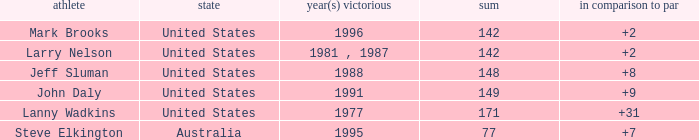Name the To par that has a Year(s) won of 1988 and a Total smaller than 148? None. Can you give me this table as a dict? {'header': ['athlete', 'state', 'year(s) victorious', 'sum', 'in comparison to par'], 'rows': [['Mark Brooks', 'United States', '1996', '142', '+2'], ['Larry Nelson', 'United States', '1981 , 1987', '142', '+2'], ['Jeff Sluman', 'United States', '1988', '148', '+8'], ['John Daly', 'United States', '1991', '149', '+9'], ['Lanny Wadkins', 'United States', '1977', '171', '+31'], ['Steve Elkington', 'Australia', '1995', '77', '+7']]} 